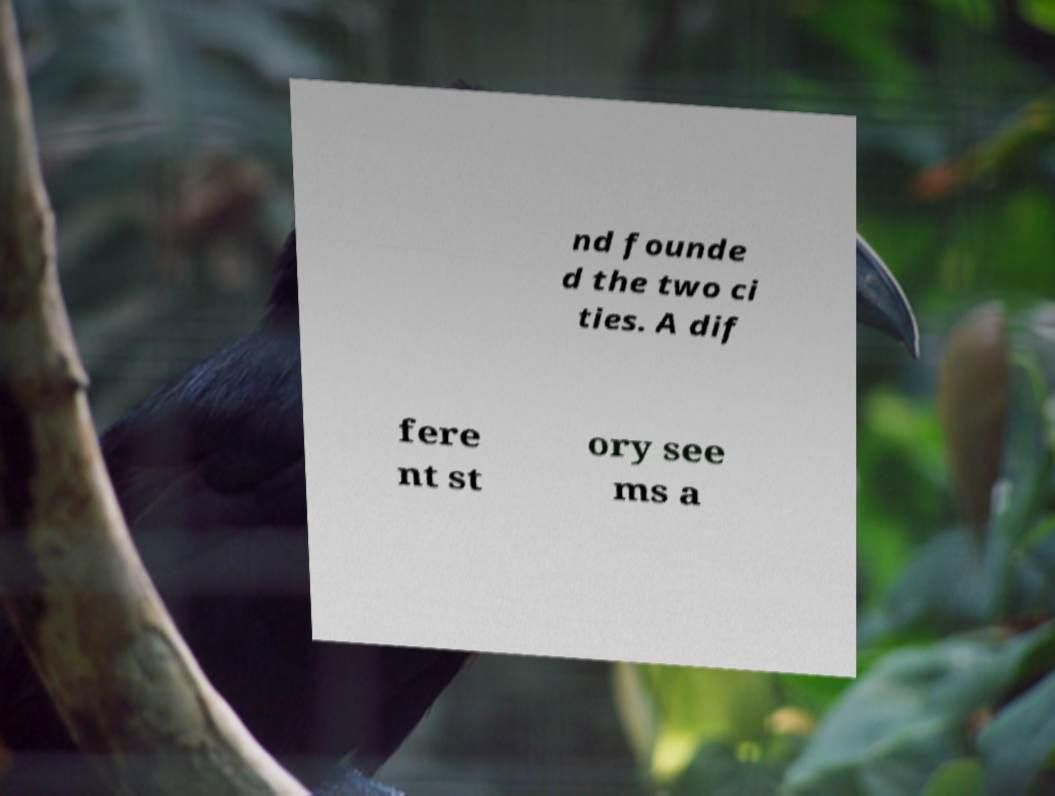I need the written content from this picture converted into text. Can you do that? nd founde d the two ci ties. A dif fere nt st ory see ms a 